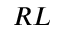Convert formula to latex. <formula><loc_0><loc_0><loc_500><loc_500>R L</formula> 